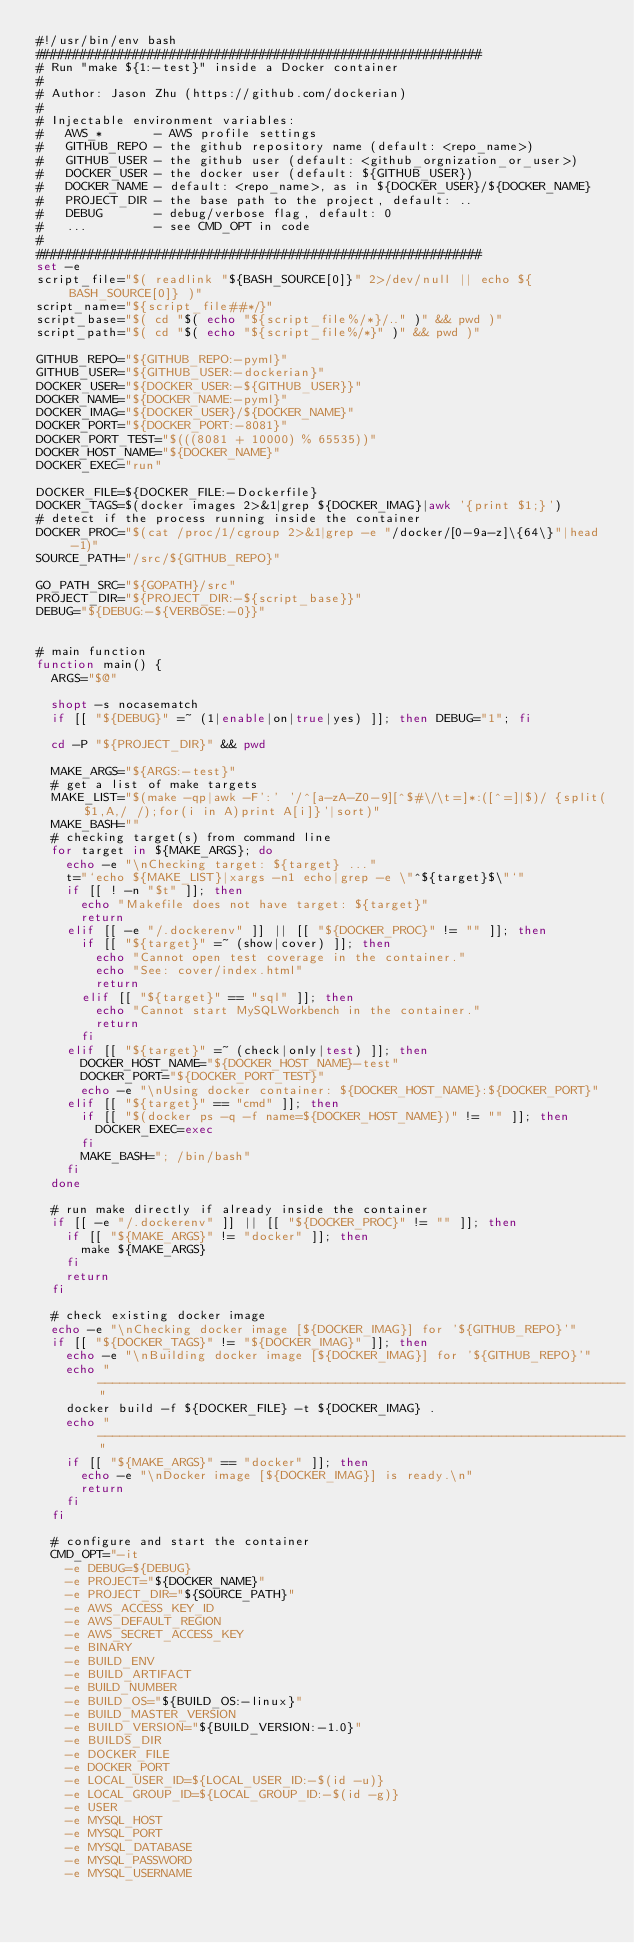<code> <loc_0><loc_0><loc_500><loc_500><_Bash_>#!/usr/bin/env bash
############################################################
# Run "make ${1:-test}" inside a Docker container
#
# Author: Jason Zhu (https://github.com/dockerian)
#
# Injectable environment variables:
#   AWS_*       - AWS profile settings
#   GITHUB_REPO - the github repository name (default: <repo_name>)
#   GITHUB_USER - the github user (default: <github_orgnization_or_user>)
#   DOCKER_USER - the docker user (default: ${GITHUB_USER})
#   DOCKER_NAME - default: <repo_name>, as in ${DOCKER_USER}/${DOCKER_NAME}
#   PROJECT_DIR - the base path to the project, default: ..
#   DEBUG       - debug/verbose flag, default: 0
#   ...         - see CMD_OPT in code
#
############################################################
set -e
script_file="$( readlink "${BASH_SOURCE[0]}" 2>/dev/null || echo ${BASH_SOURCE[0]} )"
script_name="${script_file##*/}"
script_base="$( cd "$( echo "${script_file%/*}/.." )" && pwd )"
script_path="$( cd "$( echo "${script_file%/*}" )" && pwd )"

GITHUB_REPO="${GITHUB_REPO:-pyml}"
GITHUB_USER="${GITHUB_USER:-dockerian}"
DOCKER_USER="${DOCKER_USER:-${GITHUB_USER}}"
DOCKER_NAME="${DOCKER_NAME:-pyml}"
DOCKER_IMAG="${DOCKER_USER}/${DOCKER_NAME}"
DOCKER_PORT="${DOCKER_PORT:-8081}"
DOCKER_PORT_TEST="$(((8081 + 10000) % 65535))"
DOCKER_HOST_NAME="${DOCKER_NAME}"
DOCKER_EXEC="run"

DOCKER_FILE=${DOCKER_FILE:-Dockerfile}
DOCKER_TAGS=$(docker images 2>&1|grep ${DOCKER_IMAG}|awk '{print $1;}')
# detect if the process running inside the container
DOCKER_PROC="$(cat /proc/1/cgroup 2>&1|grep -e "/docker/[0-9a-z]\{64\}"|head -1)"
SOURCE_PATH="/src/${GITHUB_REPO}"

GO_PATH_SRC="${GOPATH}/src"
PROJECT_DIR="${PROJECT_DIR:-${script_base}}"
DEBUG="${DEBUG:-${VERBOSE:-0}}"


# main function
function main() {
  ARGS="$@"

  shopt -s nocasematch
  if [[ "${DEBUG}" =~ (1|enable|on|true|yes) ]]; then DEBUG="1"; fi

  cd -P "${PROJECT_DIR}" && pwd

  MAKE_ARGS="${ARGS:-test}"
  # get a list of make targets
  MAKE_LIST="$(make -qp|awk -F':' '/^[a-zA-Z0-9][^$#\/\t=]*:([^=]|$)/ {split($1,A,/ /);for(i in A)print A[i]}'|sort)"
  MAKE_BASH=""
  # checking target(s) from command line
  for target in ${MAKE_ARGS}; do
    echo -e "\nChecking target: ${target} ..."
    t="`echo ${MAKE_LIST}|xargs -n1 echo|grep -e \"^${target}$\"`"
    if [[ ! -n "$t" ]]; then
      echo "Makefile does not have target: ${target}"
      return
    elif [[ -e "/.dockerenv" ]] || [[ "${DOCKER_PROC}" != "" ]]; then
      if [[ "${target}" =~ (show|cover) ]]; then
        echo "Cannot open test coverage in the container."
        echo "See: cover/index.html"
        return
      elif [[ "${target}" == "sql" ]]; then
        echo "Cannot start MySQLWorkbench in the container."
        return
      fi
    elif [[ "${target}" =~ (check|only|test) ]]; then
      DOCKER_HOST_NAME="${DOCKER_HOST_NAME}-test"
      DOCKER_PORT="${DOCKER_PORT_TEST}"
      echo -e "\nUsing docker container: ${DOCKER_HOST_NAME}:${DOCKER_PORT}"
    elif [[ "${target}" == "cmd" ]]; then
      if [[ "$(docker ps -q -f name=${DOCKER_HOST_NAME})" != "" ]]; then
        DOCKER_EXEC=exec
      fi
      MAKE_BASH="; /bin/bash"
    fi
  done

  # run make directly if already inside the container
  if [[ -e "/.dockerenv" ]] || [[ "${DOCKER_PROC}" != "" ]]; then
    if [[ "${MAKE_ARGS}" != "docker" ]]; then
      make ${MAKE_ARGS}
    fi
    return
  fi

  # check existing docker image
  echo -e "\nChecking docker image [${DOCKER_IMAG}] for '${GITHUB_REPO}'"
  if [[ "${DOCKER_TAGS}" != "${DOCKER_IMAG}" ]]; then
    echo -e "\nBuilding docker image [${DOCKER_IMAG}] for '${GITHUB_REPO}'"
    echo "-----------------------------------------------------------------------"
    docker build -f ${DOCKER_FILE} -t ${DOCKER_IMAG} .
    echo "-----------------------------------------------------------------------"
    if [[ "${MAKE_ARGS}" == "docker" ]]; then
      echo -e "\nDocker image [${DOCKER_IMAG}] is ready.\n"
      return
    fi
  fi

  # configure and start the container
  CMD_OPT="-it
    -e DEBUG=${DEBUG}
    -e PROJECT="${DOCKER_NAME}"
    -e PROJECT_DIR="${SOURCE_PATH}"
    -e AWS_ACCESS_KEY_ID
    -e AWS_DEFAULT_REGION
    -e AWS_SECRET_ACCESS_KEY
    -e BINARY
    -e BUILD_ENV
    -e BUILD_ARTIFACT
    -e BUILD_NUMBER
    -e BUILD_OS="${BUILD_OS:-linux}"
    -e BUILD_MASTER_VERSION
    -e BUILD_VERSION="${BUILD_VERSION:-1.0}"
    -e BUILDS_DIR
    -e DOCKER_FILE
    -e DOCKER_PORT
    -e LOCAL_USER_ID=${LOCAL_USER_ID:-$(id -u)}
    -e LOCAL_GROUP_ID=${LOCAL_GROUP_ID:-$(id -g)}
    -e USER
    -e MYSQL_HOST
    -e MYSQL_PORT
    -e MYSQL_DATABASE
    -e MYSQL_PASSWORD
    -e MYSQL_USERNAME</code> 